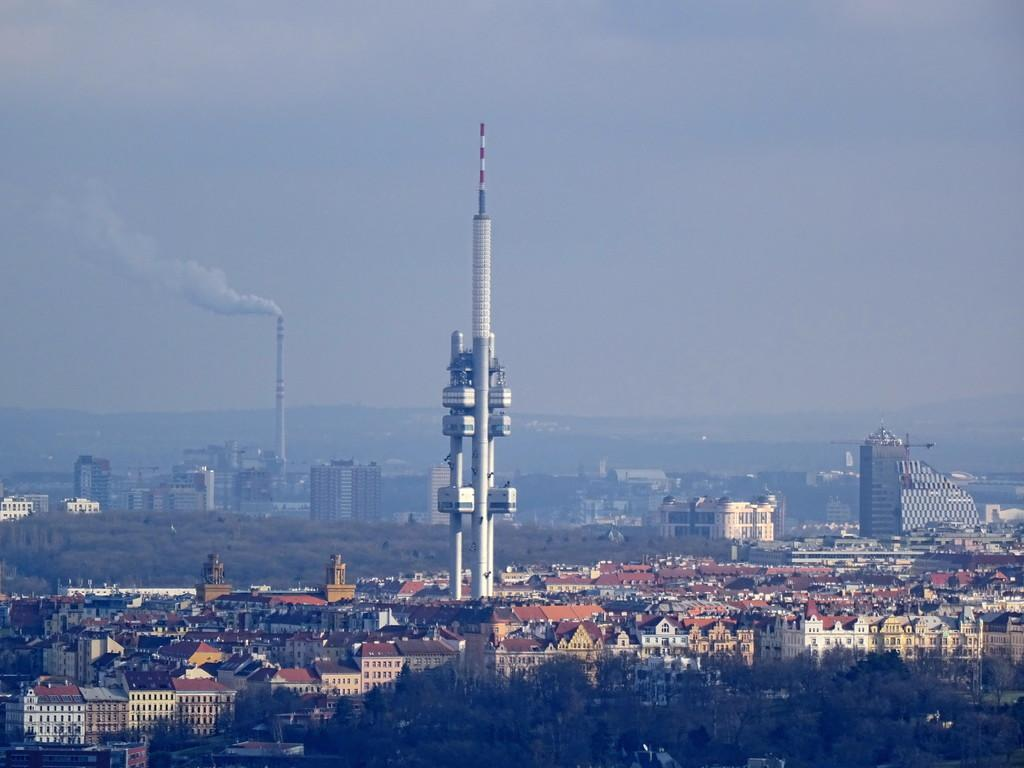What type of natural elements can be seen in the image? There are trees in the image. What type of man-made structures are present in the image? There are buildings in the image. What type of geographical feature can be seen in the distance? There are mountains visible in the image. What part of the natural environment is visible in the image? The sky is visible in the image. Can you tell me how many snails are crawling on the side of the building in the image? There are no snails present in the image; it features trees, buildings, mountains, and the sky. What type of mine is visible in the image? There is no mine present in the image. 